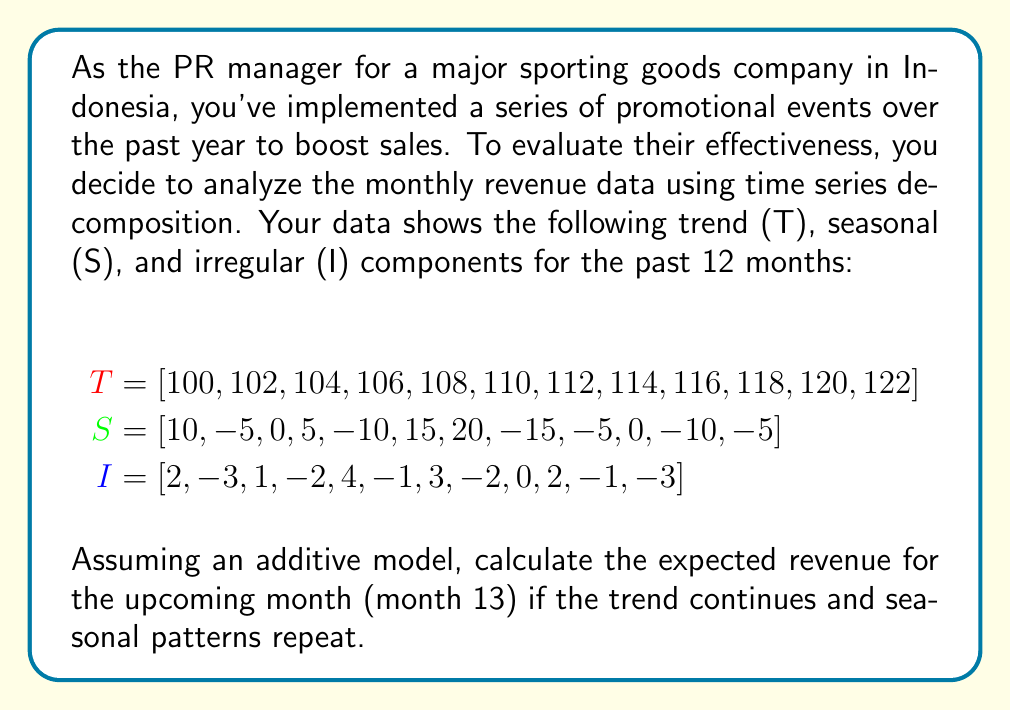Can you answer this question? To solve this problem, we'll use the additive time series decomposition model:

$$Y_t = T_t + S_t + I_t$$

Where:
$Y_t$ is the observed value
$T_t$ is the trend component
$S_t$ is the seasonal component
$I_t$ is the irregular component

Steps to solve:

1. Identify the trend for month 13:
   The trend seems to increase by 2 each month. For month 13, it would be:
   $$T_{13} = 122 + 2 = 124$$

2. Identify the seasonal component for month 13:
   The seasonal pattern repeats every 12 months, so month 13 will have the same seasonal component as month 1:
   $$S_{13} = S_1 = 10$$

3. For the irregular component, we cannot predict its exact value as it's random. In forecasting, we typically use the expected value of the irregular component, which is zero:
   $$E(I_{13}) = 0$$

4. Combine the components using the additive model:
   $$Y_{13} = T_{13} + S_{13} + E(I_{13}) = 124 + 10 + 0 = 134$$

Therefore, the expected revenue for month 13 is 134 (in whatever units the original data was measured, likely millions of Indonesian Rupiah).
Answer: 134 